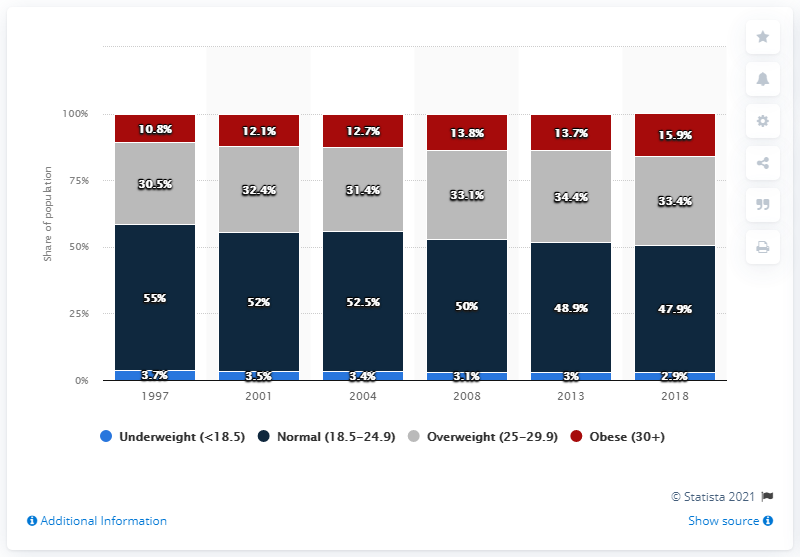Draw attention to some important aspects in this diagram. The share of underweight Belgians decreased in 1997. 